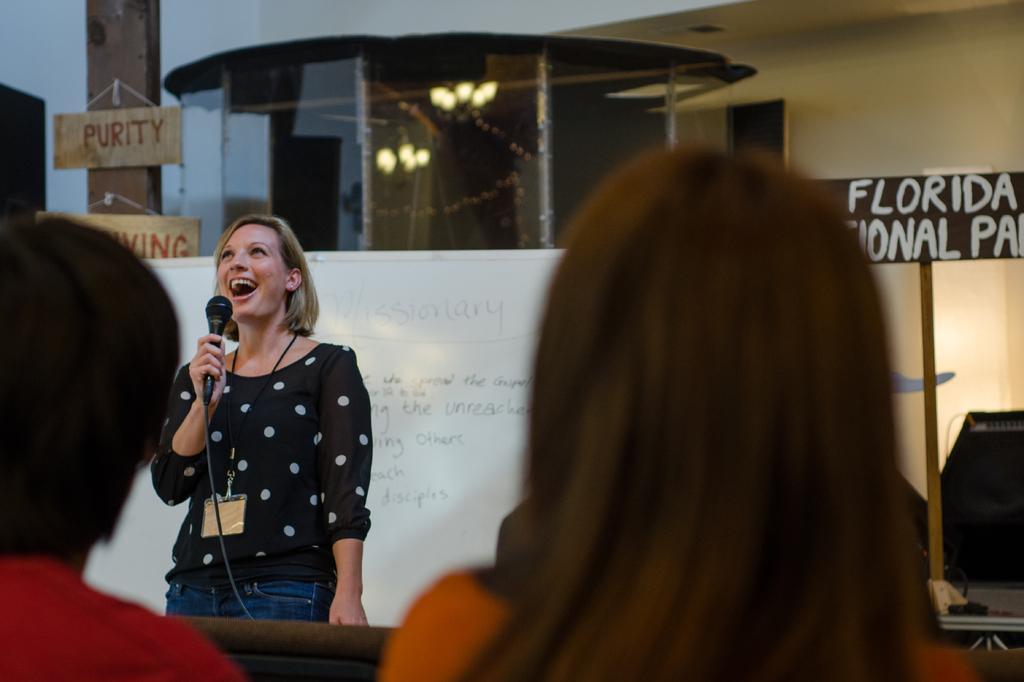In one or two sentences, can you explain what this image depicts? In this picture there is a woman at the left side of the image, who is laughing by holding a mice in her hand and there are two people those who are sitting before the lady, there is a board behind the lady and something is written on it, there is a word of purity and living behind the lady which is hanged on a pole and there is a glass window behind the lady, the lady who is speaking in front of the audience wearing an identity card. 